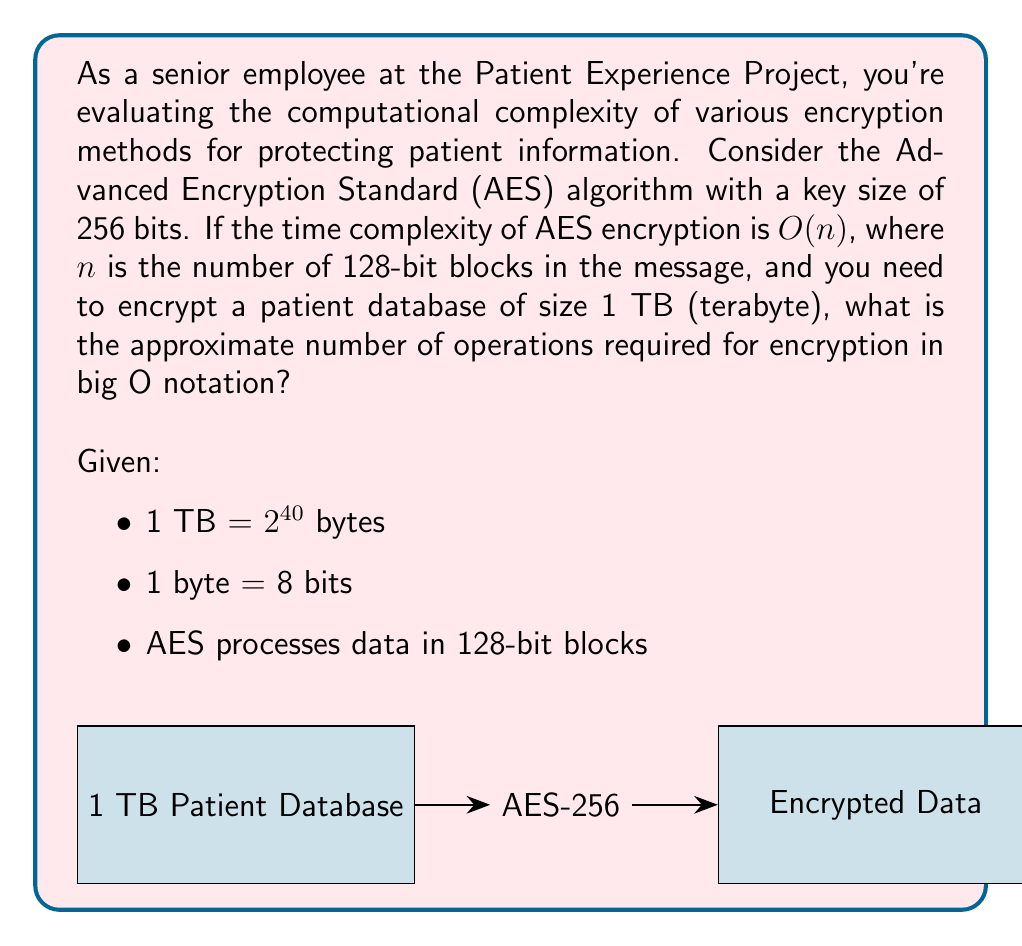Can you answer this question? Let's approach this step-by-step:

1) First, we need to calculate how many 128-bit blocks are in 1 TB of data.

2) 1 TB = $2^{40}$ bytes
   1 byte = 8 bits
   So, 1 TB = $2^{40} \times 8 = 2^{43}$ bits

3) Each AES block is 128 bits. To find the number of blocks, we divide the total number of bits by 128:

   $n = \frac{2^{43}}{128} = \frac{2^{43}}{2^7} = 2^{36}$

4) The time complexity of AES is $O(n)$, where $n$ is the number of blocks.

5) Therefore, the number of operations required is $O(2^{36})$.

6) In big O notation, we typically simplify constant bases. So we can write this as $O(2^{36}) = O(2^n)$, where $n = 36$.
Answer: $O(2^n)$, where $n = 36$ 